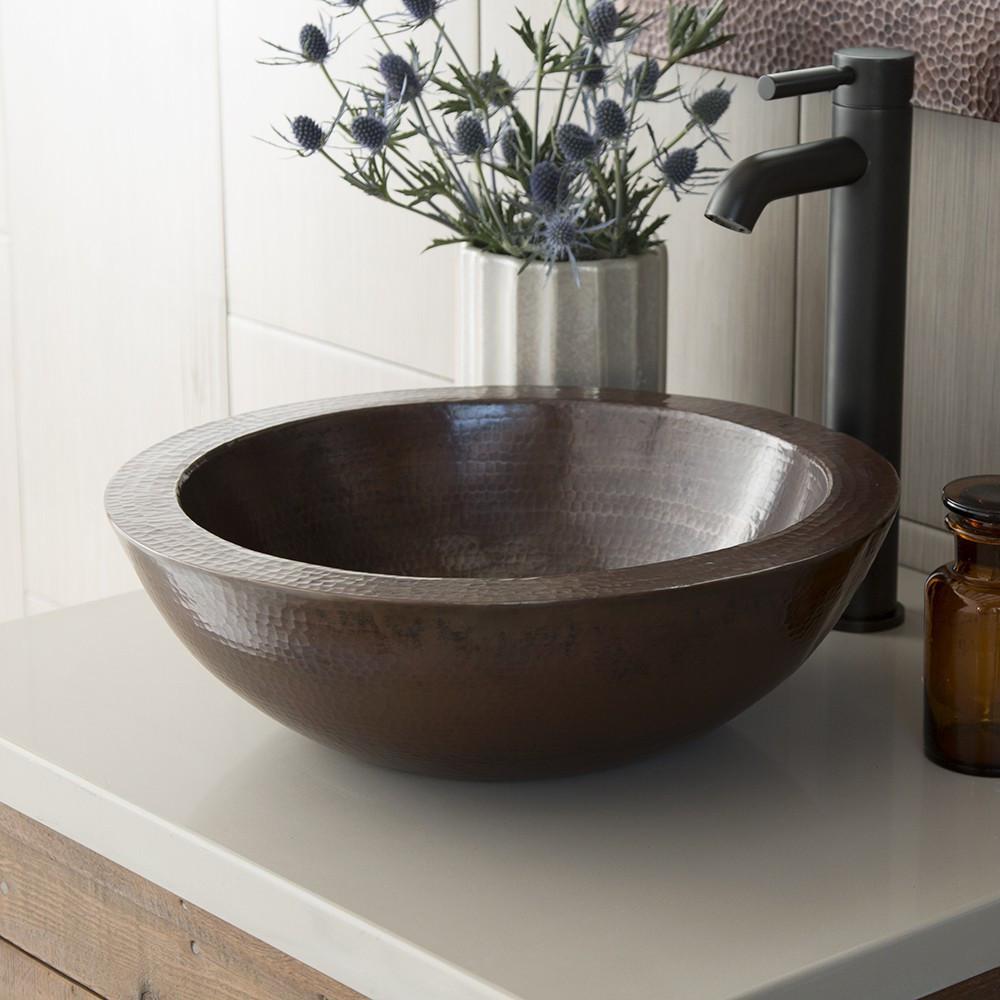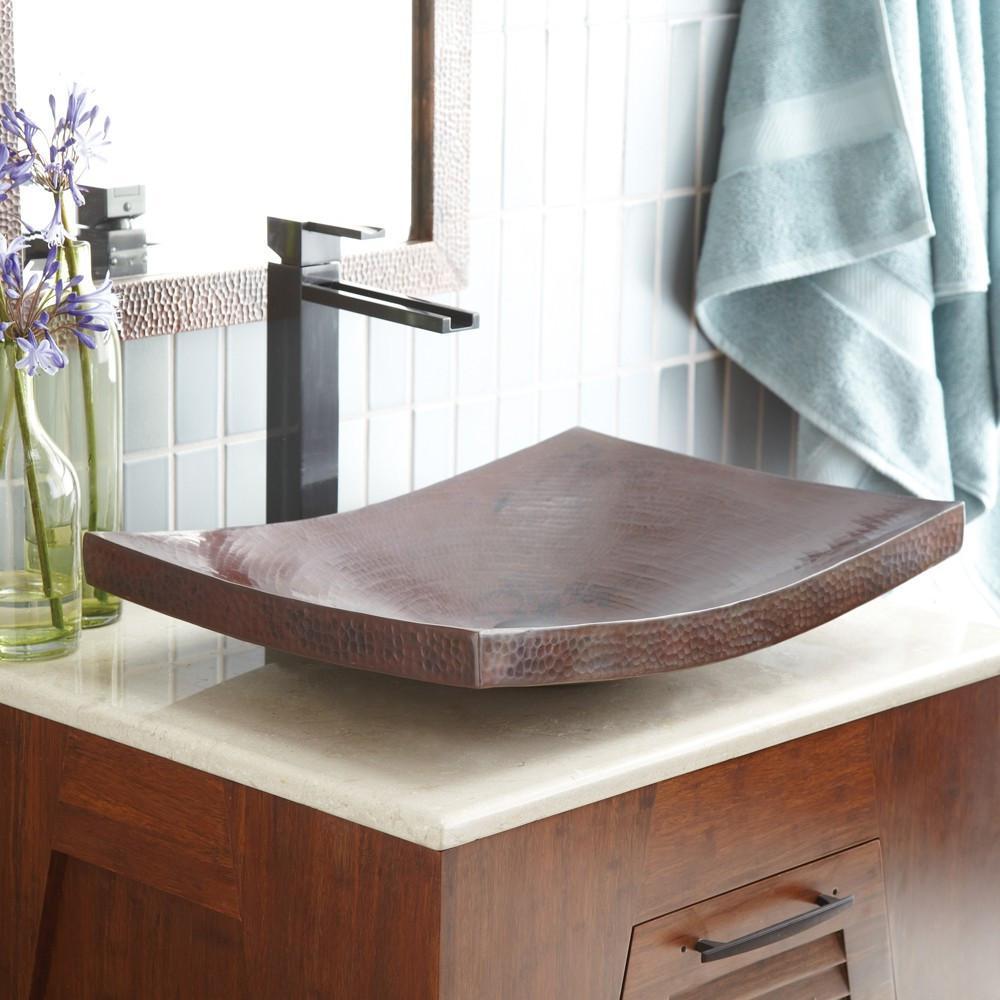The first image is the image on the left, the second image is the image on the right. For the images displayed, is the sentence "There is an item next to a sink." factually correct? Answer yes or no. Yes. The first image is the image on the left, the second image is the image on the right. Given the left and right images, does the statement "Sinks on the left and right share the same shape and faucet style." hold true? Answer yes or no. No. 